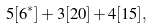<formula> <loc_0><loc_0><loc_500><loc_500>5 [ 6 ^ { * } ] + 3 [ 2 0 ] + 4 [ 1 5 ] ,</formula> 